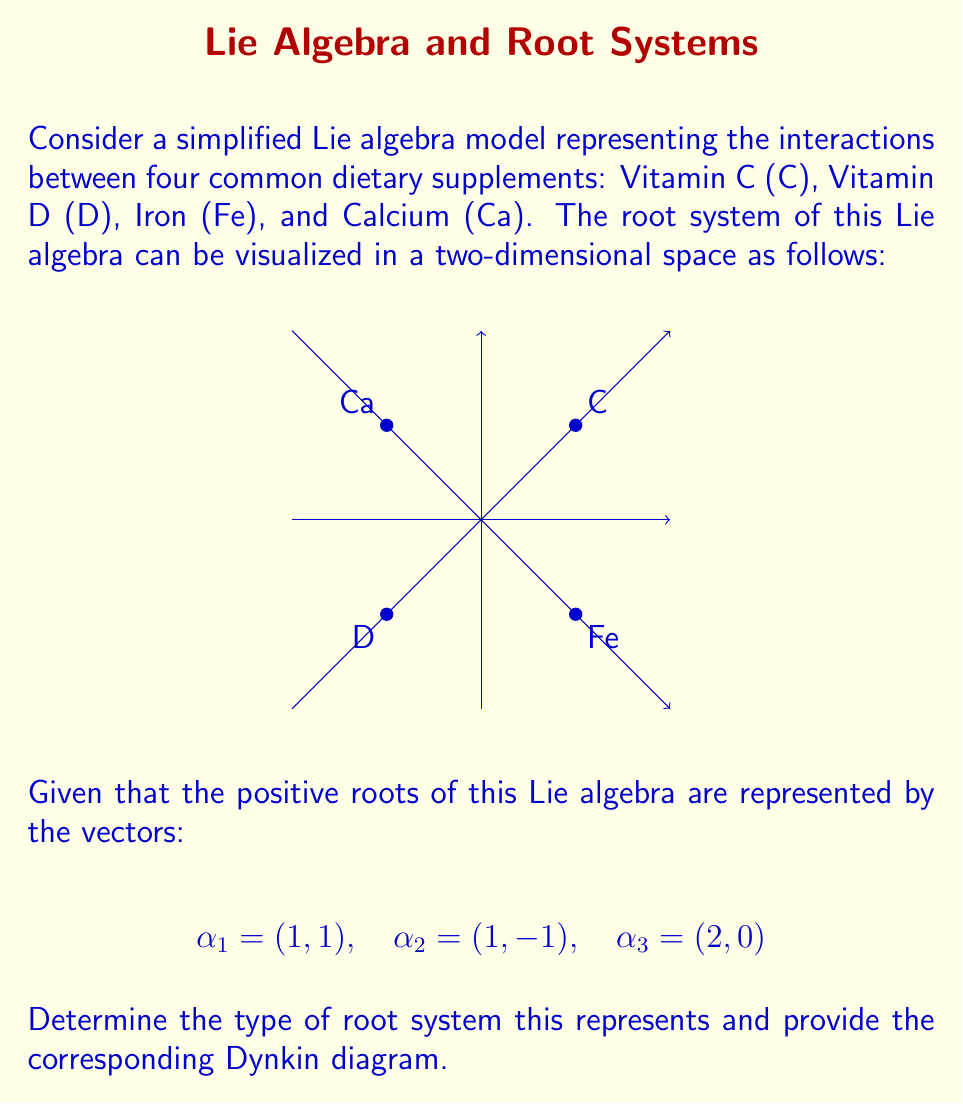Teach me how to tackle this problem. To solve this problem, we'll follow these steps:

1) First, we need to identify the simple roots. In a root system, simple roots are the positive roots that cannot be written as a sum of other positive roots. From the given positive roots:

   $\alpha_1 = (1,1)$ and $\alpha_2 = (1,-1)$ are simple roots
   $\alpha_3 = (2,0) = \alpha_1 + \alpha_2$

2) Now that we have identified the simple roots, we can determine the angles between them. The angle $\theta$ between two vectors $\mathbf{a}$ and $\mathbf{b}$ is given by:

   $$\cos \theta = \frac{\mathbf{a} \cdot \mathbf{b}}{|\mathbf{a}||\mathbf{b}|}$$

3) For $\alpha_1 = (1,1)$ and $\alpha_2 = (1,-1)$:

   $$\cos \theta = \frac{(1,1) \cdot (1,-1)}{\sqrt{2}\sqrt{2}} = \frac{1-1}{2} = 0$$

   This corresponds to an angle of 90°.

4) The fact that we have two simple roots at a 90° angle to each other is characteristic of the $A_2$ root system, which corresponds to the Lie algebra $\mathfrak{sl}(3)$.

5) The Dynkin diagram for $A_2$ consists of two nodes connected by a single line:

   [asy]
   unitsize(0.5cm);
   dot((0,0));
   dot((2,0));
   draw((0,0)--(2,0));
   [/asy]

This Dynkin diagram represents the relationship between the simple roots, where each node represents a simple root and the line indicates that the roots are not orthogonal.
Answer: $A_2$ root system; Dynkin diagram: [asy]unitsize(0.5cm);dot((0,0));dot((2,0));draw((0,0)--(2,0));[/asy] 